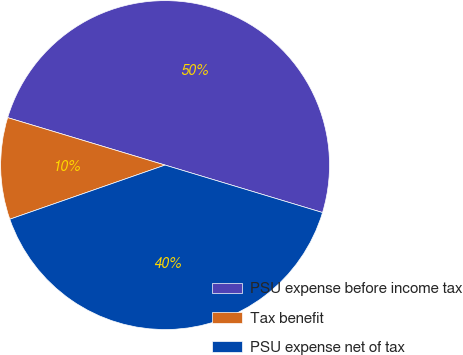<chart> <loc_0><loc_0><loc_500><loc_500><pie_chart><fcel>PSU expense before income tax<fcel>Tax benefit<fcel>PSU expense net of tax<nl><fcel>50.0%<fcel>10.0%<fcel>40.0%<nl></chart> 